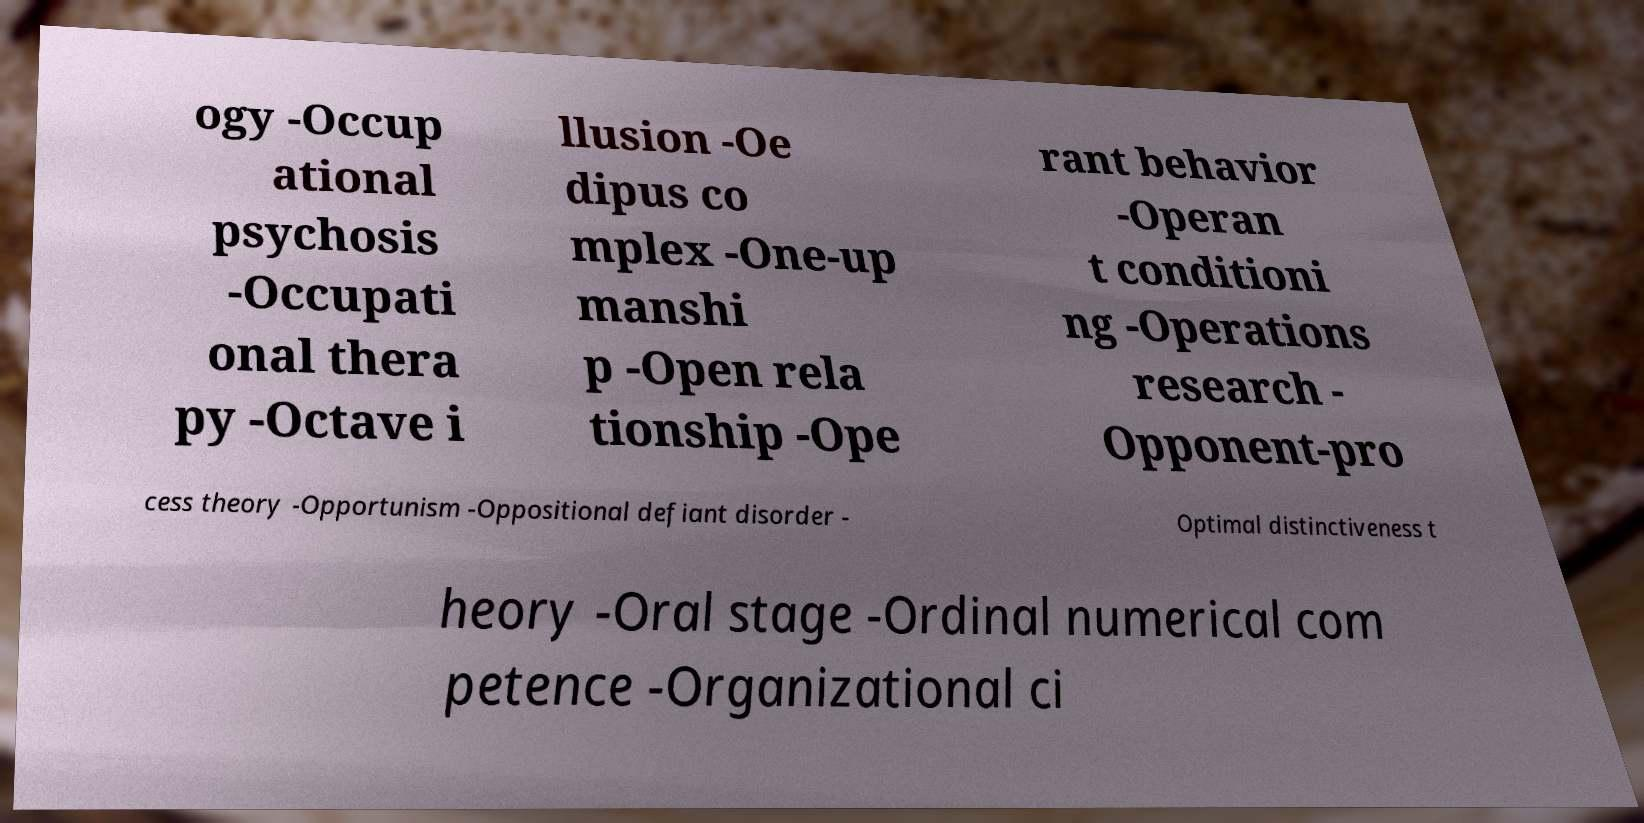Please identify and transcribe the text found in this image. ogy -Occup ational psychosis -Occupati onal thera py -Octave i llusion -Oe dipus co mplex -One-up manshi p -Open rela tionship -Ope rant behavior -Operan t conditioni ng -Operations research - Opponent-pro cess theory -Opportunism -Oppositional defiant disorder - Optimal distinctiveness t heory -Oral stage -Ordinal numerical com petence -Organizational ci 